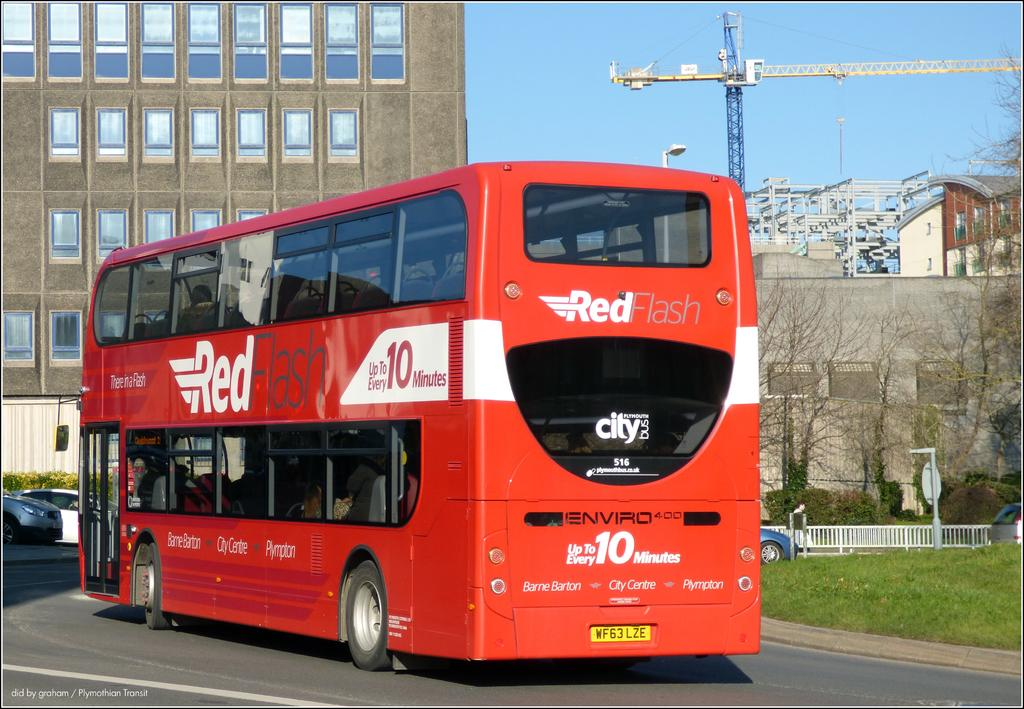<image>
Create a compact narrative representing the image presented. A large red bus advertises that it will arrive "up to every 10 minutes" 